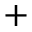Convert formula to latex. <formula><loc_0><loc_0><loc_500><loc_500>+</formula> 